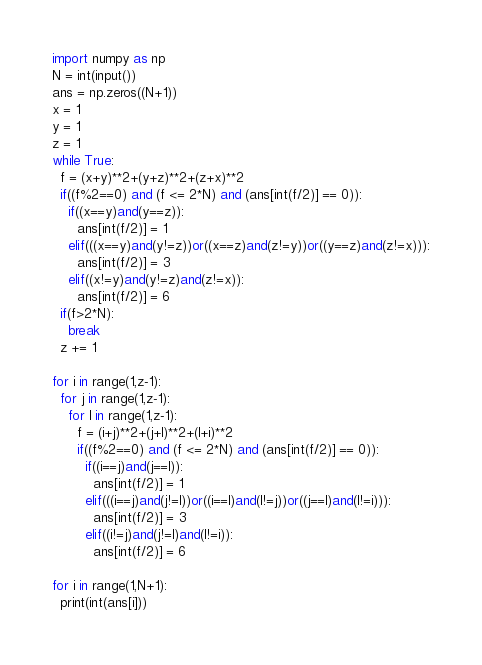<code> <loc_0><loc_0><loc_500><loc_500><_Python_>import numpy as np
N = int(input())
ans = np.zeros((N+1))
x = 1
y = 1
z = 1
while True:
  f = (x+y)**2+(y+z)**2+(z+x)**2
  if((f%2==0) and (f <= 2*N) and (ans[int(f/2)] == 0)):
    if((x==y)and(y==z)):
      ans[int(f/2)] = 1
    elif(((x==y)and(y!=z))or((x==z)and(z!=y))or((y==z)and(z!=x))):
      ans[int(f/2)] = 3
    elif((x!=y)and(y!=z)and(z!=x)):
      ans[int(f/2)] = 6
  if(f>2*N):
    break
  z += 1

for i in range(1,z-1):
  for j in range(1,z-1):
    for l in range(1,z-1):
      f = (i+j)**2+(j+l)**2+(l+i)**2
      if((f%2==0) and (f <= 2*N) and (ans[int(f/2)] == 0)):
        if((i==j)and(j==l)):
          ans[int(f/2)] = 1
        elif(((i==j)and(j!=l))or((i==l)and(l!=j))or((j==l)and(l!=i))):
          ans[int(f/2)] = 3
        elif((i!=j)and(j!=l)and(l!=i)):
          ans[int(f/2)] = 6

for i in range(1,N+1):
  print(int(ans[i]))</code> 